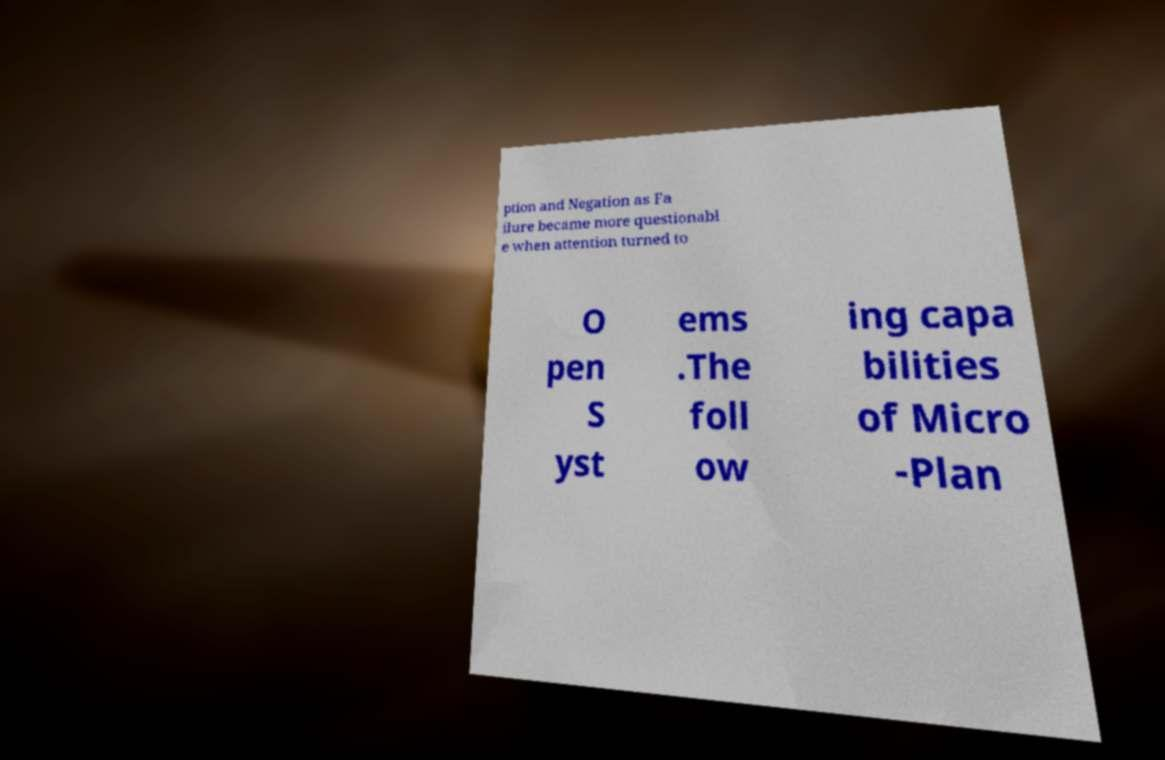Can you accurately transcribe the text from the provided image for me? ption and Negation as Fa ilure became more questionabl e when attention turned to O pen S yst ems .The foll ow ing capa bilities of Micro -Plan 